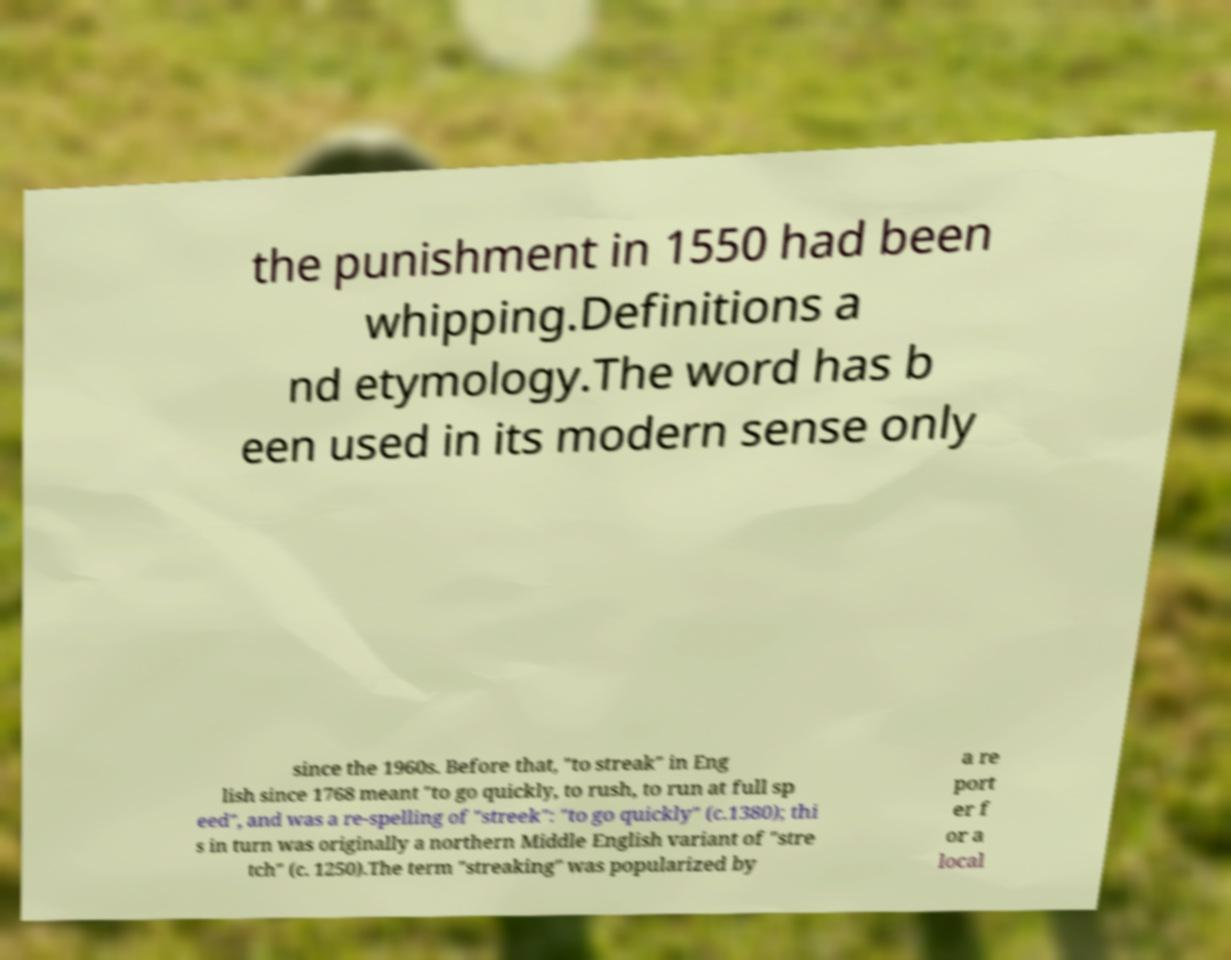What messages or text are displayed in this image? I need them in a readable, typed format. the punishment in 1550 had been whipping.Definitions a nd etymology.The word has b een used in its modern sense only since the 1960s. Before that, "to streak" in Eng lish since 1768 meant "to go quickly, to rush, to run at full sp eed", and was a re-spelling of "streek": "to go quickly" (c.1380); thi s in turn was originally a northern Middle English variant of "stre tch" (c. 1250).The term "streaking" was popularized by a re port er f or a local 